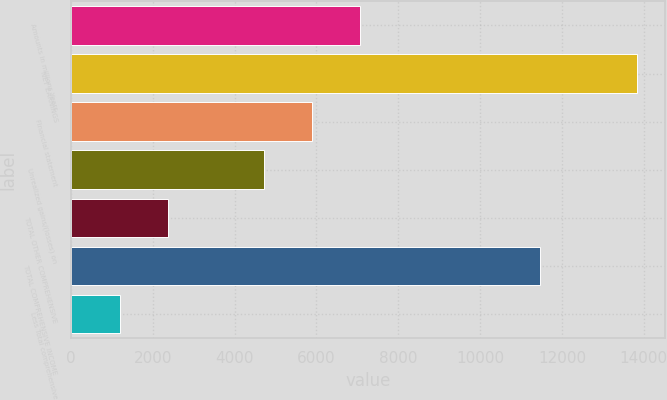Convert chart to OTSL. <chart><loc_0><loc_0><loc_500><loc_500><bar_chart><fcel>Amounts in millions Years<fcel>NET EARNINGS<fcel>Financial statement<fcel>Unrealized gains/(losses) on<fcel>TOTAL OTHER COMPREHENSIVE<fcel>TOTAL COMPREHENSIVE INCOME<fcel>Less Total comprehensive<nl><fcel>7074.6<fcel>13827.2<fcel>5897<fcel>4719.4<fcel>2364.2<fcel>11472<fcel>1186.6<nl></chart> 